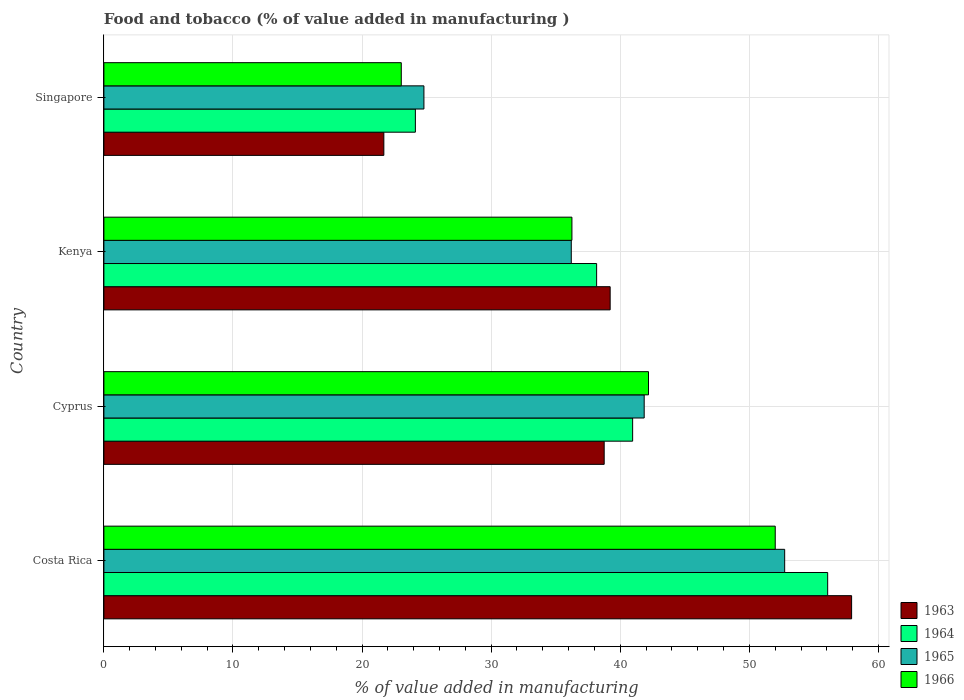How many different coloured bars are there?
Offer a very short reply. 4. How many bars are there on the 2nd tick from the top?
Make the answer very short. 4. What is the label of the 3rd group of bars from the top?
Provide a succinct answer. Cyprus. In how many cases, is the number of bars for a given country not equal to the number of legend labels?
Keep it short and to the point. 0. What is the value added in manufacturing food and tobacco in 1965 in Kenya?
Give a very brief answer. 36.2. Across all countries, what is the maximum value added in manufacturing food and tobacco in 1963?
Make the answer very short. 57.92. Across all countries, what is the minimum value added in manufacturing food and tobacco in 1965?
Offer a terse response. 24.79. In which country was the value added in manufacturing food and tobacco in 1964 minimum?
Make the answer very short. Singapore. What is the total value added in manufacturing food and tobacco in 1966 in the graph?
Keep it short and to the point. 153.48. What is the difference between the value added in manufacturing food and tobacco in 1966 in Costa Rica and that in Cyprus?
Offer a very short reply. 9.82. What is the difference between the value added in manufacturing food and tobacco in 1964 in Costa Rica and the value added in manufacturing food and tobacco in 1963 in Singapore?
Make the answer very short. 34.38. What is the average value added in manufacturing food and tobacco in 1963 per country?
Your response must be concise. 39.39. What is the difference between the value added in manufacturing food and tobacco in 1965 and value added in manufacturing food and tobacco in 1963 in Kenya?
Keep it short and to the point. -3.01. What is the ratio of the value added in manufacturing food and tobacco in 1963 in Costa Rica to that in Cyprus?
Ensure brevity in your answer.  1.49. Is the value added in manufacturing food and tobacco in 1965 in Cyprus less than that in Singapore?
Offer a very short reply. No. What is the difference between the highest and the second highest value added in manufacturing food and tobacco in 1964?
Your answer should be very brief. 15.11. What is the difference between the highest and the lowest value added in manufacturing food and tobacco in 1965?
Your answer should be very brief. 27.94. Is it the case that in every country, the sum of the value added in manufacturing food and tobacco in 1966 and value added in manufacturing food and tobacco in 1963 is greater than the sum of value added in manufacturing food and tobacco in 1964 and value added in manufacturing food and tobacco in 1965?
Ensure brevity in your answer.  No. What does the 3rd bar from the top in Cyprus represents?
Provide a succinct answer. 1964. What does the 4th bar from the bottom in Costa Rica represents?
Your answer should be compact. 1966. Are all the bars in the graph horizontal?
Make the answer very short. Yes. How many countries are there in the graph?
Keep it short and to the point. 4. Does the graph contain any zero values?
Provide a short and direct response. No. How are the legend labels stacked?
Your answer should be very brief. Vertical. What is the title of the graph?
Make the answer very short. Food and tobacco (% of value added in manufacturing ). Does "2008" appear as one of the legend labels in the graph?
Ensure brevity in your answer.  No. What is the label or title of the X-axis?
Offer a very short reply. % of value added in manufacturing. What is the % of value added in manufacturing in 1963 in Costa Rica?
Offer a terse response. 57.92. What is the % of value added in manufacturing of 1964 in Costa Rica?
Offer a very short reply. 56.07. What is the % of value added in manufacturing in 1965 in Costa Rica?
Ensure brevity in your answer.  52.73. What is the % of value added in manufacturing in 1966 in Costa Rica?
Make the answer very short. 52. What is the % of value added in manufacturing of 1963 in Cyprus?
Ensure brevity in your answer.  38.75. What is the % of value added in manufacturing in 1964 in Cyprus?
Your answer should be compact. 40.96. What is the % of value added in manufacturing of 1965 in Cyprus?
Ensure brevity in your answer.  41.85. What is the % of value added in manufacturing of 1966 in Cyprus?
Your response must be concise. 42.19. What is the % of value added in manufacturing of 1963 in Kenya?
Ensure brevity in your answer.  39.22. What is the % of value added in manufacturing of 1964 in Kenya?
Make the answer very short. 38.17. What is the % of value added in manufacturing of 1965 in Kenya?
Provide a succinct answer. 36.2. What is the % of value added in manufacturing of 1966 in Kenya?
Your response must be concise. 36.25. What is the % of value added in manufacturing of 1963 in Singapore?
Offer a terse response. 21.69. What is the % of value added in manufacturing in 1964 in Singapore?
Ensure brevity in your answer.  24.13. What is the % of value added in manufacturing of 1965 in Singapore?
Provide a short and direct response. 24.79. What is the % of value added in manufacturing in 1966 in Singapore?
Make the answer very short. 23.04. Across all countries, what is the maximum % of value added in manufacturing of 1963?
Provide a short and direct response. 57.92. Across all countries, what is the maximum % of value added in manufacturing of 1964?
Make the answer very short. 56.07. Across all countries, what is the maximum % of value added in manufacturing of 1965?
Your answer should be compact. 52.73. Across all countries, what is the maximum % of value added in manufacturing of 1966?
Offer a very short reply. 52. Across all countries, what is the minimum % of value added in manufacturing of 1963?
Your answer should be compact. 21.69. Across all countries, what is the minimum % of value added in manufacturing in 1964?
Make the answer very short. 24.13. Across all countries, what is the minimum % of value added in manufacturing of 1965?
Make the answer very short. 24.79. Across all countries, what is the minimum % of value added in manufacturing in 1966?
Your response must be concise. 23.04. What is the total % of value added in manufacturing of 1963 in the graph?
Your response must be concise. 157.58. What is the total % of value added in manufacturing of 1964 in the graph?
Offer a very short reply. 159.32. What is the total % of value added in manufacturing in 1965 in the graph?
Your response must be concise. 155.58. What is the total % of value added in manufacturing of 1966 in the graph?
Offer a terse response. 153.48. What is the difference between the % of value added in manufacturing in 1963 in Costa Rica and that in Cyprus?
Give a very brief answer. 19.17. What is the difference between the % of value added in manufacturing of 1964 in Costa Rica and that in Cyprus?
Make the answer very short. 15.11. What is the difference between the % of value added in manufacturing of 1965 in Costa Rica and that in Cyprus?
Your response must be concise. 10.88. What is the difference between the % of value added in manufacturing in 1966 in Costa Rica and that in Cyprus?
Ensure brevity in your answer.  9.82. What is the difference between the % of value added in manufacturing in 1963 in Costa Rica and that in Kenya?
Your answer should be compact. 18.7. What is the difference between the % of value added in manufacturing of 1964 in Costa Rica and that in Kenya?
Ensure brevity in your answer.  17.9. What is the difference between the % of value added in manufacturing of 1965 in Costa Rica and that in Kenya?
Offer a terse response. 16.53. What is the difference between the % of value added in manufacturing of 1966 in Costa Rica and that in Kenya?
Make the answer very short. 15.75. What is the difference between the % of value added in manufacturing in 1963 in Costa Rica and that in Singapore?
Make the answer very short. 36.23. What is the difference between the % of value added in manufacturing in 1964 in Costa Rica and that in Singapore?
Your answer should be compact. 31.94. What is the difference between the % of value added in manufacturing in 1965 in Costa Rica and that in Singapore?
Provide a succinct answer. 27.94. What is the difference between the % of value added in manufacturing in 1966 in Costa Rica and that in Singapore?
Provide a short and direct response. 28.97. What is the difference between the % of value added in manufacturing in 1963 in Cyprus and that in Kenya?
Give a very brief answer. -0.46. What is the difference between the % of value added in manufacturing of 1964 in Cyprus and that in Kenya?
Keep it short and to the point. 2.79. What is the difference between the % of value added in manufacturing in 1965 in Cyprus and that in Kenya?
Give a very brief answer. 5.65. What is the difference between the % of value added in manufacturing of 1966 in Cyprus and that in Kenya?
Provide a succinct answer. 5.93. What is the difference between the % of value added in manufacturing in 1963 in Cyprus and that in Singapore?
Provide a succinct answer. 17.07. What is the difference between the % of value added in manufacturing of 1964 in Cyprus and that in Singapore?
Offer a terse response. 16.83. What is the difference between the % of value added in manufacturing of 1965 in Cyprus and that in Singapore?
Give a very brief answer. 17.06. What is the difference between the % of value added in manufacturing in 1966 in Cyprus and that in Singapore?
Your response must be concise. 19.15. What is the difference between the % of value added in manufacturing of 1963 in Kenya and that in Singapore?
Your answer should be compact. 17.53. What is the difference between the % of value added in manufacturing in 1964 in Kenya and that in Singapore?
Ensure brevity in your answer.  14.04. What is the difference between the % of value added in manufacturing of 1965 in Kenya and that in Singapore?
Your response must be concise. 11.41. What is the difference between the % of value added in manufacturing of 1966 in Kenya and that in Singapore?
Offer a terse response. 13.22. What is the difference between the % of value added in manufacturing in 1963 in Costa Rica and the % of value added in manufacturing in 1964 in Cyprus?
Give a very brief answer. 16.96. What is the difference between the % of value added in manufacturing of 1963 in Costa Rica and the % of value added in manufacturing of 1965 in Cyprus?
Give a very brief answer. 16.07. What is the difference between the % of value added in manufacturing in 1963 in Costa Rica and the % of value added in manufacturing in 1966 in Cyprus?
Provide a short and direct response. 15.73. What is the difference between the % of value added in manufacturing of 1964 in Costa Rica and the % of value added in manufacturing of 1965 in Cyprus?
Offer a very short reply. 14.21. What is the difference between the % of value added in manufacturing of 1964 in Costa Rica and the % of value added in manufacturing of 1966 in Cyprus?
Offer a terse response. 13.88. What is the difference between the % of value added in manufacturing in 1965 in Costa Rica and the % of value added in manufacturing in 1966 in Cyprus?
Your answer should be compact. 10.55. What is the difference between the % of value added in manufacturing of 1963 in Costa Rica and the % of value added in manufacturing of 1964 in Kenya?
Your answer should be very brief. 19.75. What is the difference between the % of value added in manufacturing of 1963 in Costa Rica and the % of value added in manufacturing of 1965 in Kenya?
Ensure brevity in your answer.  21.72. What is the difference between the % of value added in manufacturing of 1963 in Costa Rica and the % of value added in manufacturing of 1966 in Kenya?
Provide a succinct answer. 21.67. What is the difference between the % of value added in manufacturing in 1964 in Costa Rica and the % of value added in manufacturing in 1965 in Kenya?
Ensure brevity in your answer.  19.86. What is the difference between the % of value added in manufacturing in 1964 in Costa Rica and the % of value added in manufacturing in 1966 in Kenya?
Offer a very short reply. 19.81. What is the difference between the % of value added in manufacturing in 1965 in Costa Rica and the % of value added in manufacturing in 1966 in Kenya?
Offer a terse response. 16.48. What is the difference between the % of value added in manufacturing of 1963 in Costa Rica and the % of value added in manufacturing of 1964 in Singapore?
Provide a short and direct response. 33.79. What is the difference between the % of value added in manufacturing of 1963 in Costa Rica and the % of value added in manufacturing of 1965 in Singapore?
Make the answer very short. 33.13. What is the difference between the % of value added in manufacturing in 1963 in Costa Rica and the % of value added in manufacturing in 1966 in Singapore?
Your answer should be compact. 34.88. What is the difference between the % of value added in manufacturing in 1964 in Costa Rica and the % of value added in manufacturing in 1965 in Singapore?
Your response must be concise. 31.28. What is the difference between the % of value added in manufacturing of 1964 in Costa Rica and the % of value added in manufacturing of 1966 in Singapore?
Your answer should be compact. 33.03. What is the difference between the % of value added in manufacturing of 1965 in Costa Rica and the % of value added in manufacturing of 1966 in Singapore?
Your answer should be compact. 29.7. What is the difference between the % of value added in manufacturing of 1963 in Cyprus and the % of value added in manufacturing of 1964 in Kenya?
Provide a short and direct response. 0.59. What is the difference between the % of value added in manufacturing of 1963 in Cyprus and the % of value added in manufacturing of 1965 in Kenya?
Make the answer very short. 2.55. What is the difference between the % of value added in manufacturing in 1963 in Cyprus and the % of value added in manufacturing in 1966 in Kenya?
Your answer should be very brief. 2.5. What is the difference between the % of value added in manufacturing in 1964 in Cyprus and the % of value added in manufacturing in 1965 in Kenya?
Offer a terse response. 4.75. What is the difference between the % of value added in manufacturing in 1964 in Cyprus and the % of value added in manufacturing in 1966 in Kenya?
Offer a very short reply. 4.7. What is the difference between the % of value added in manufacturing of 1965 in Cyprus and the % of value added in manufacturing of 1966 in Kenya?
Ensure brevity in your answer.  5.6. What is the difference between the % of value added in manufacturing in 1963 in Cyprus and the % of value added in manufacturing in 1964 in Singapore?
Your answer should be compact. 14.63. What is the difference between the % of value added in manufacturing in 1963 in Cyprus and the % of value added in manufacturing in 1965 in Singapore?
Your answer should be very brief. 13.96. What is the difference between the % of value added in manufacturing in 1963 in Cyprus and the % of value added in manufacturing in 1966 in Singapore?
Your response must be concise. 15.72. What is the difference between the % of value added in manufacturing of 1964 in Cyprus and the % of value added in manufacturing of 1965 in Singapore?
Your answer should be compact. 16.17. What is the difference between the % of value added in manufacturing of 1964 in Cyprus and the % of value added in manufacturing of 1966 in Singapore?
Give a very brief answer. 17.92. What is the difference between the % of value added in manufacturing of 1965 in Cyprus and the % of value added in manufacturing of 1966 in Singapore?
Your answer should be compact. 18.82. What is the difference between the % of value added in manufacturing in 1963 in Kenya and the % of value added in manufacturing in 1964 in Singapore?
Make the answer very short. 15.09. What is the difference between the % of value added in manufacturing in 1963 in Kenya and the % of value added in manufacturing in 1965 in Singapore?
Make the answer very short. 14.43. What is the difference between the % of value added in manufacturing of 1963 in Kenya and the % of value added in manufacturing of 1966 in Singapore?
Keep it short and to the point. 16.18. What is the difference between the % of value added in manufacturing of 1964 in Kenya and the % of value added in manufacturing of 1965 in Singapore?
Provide a succinct answer. 13.38. What is the difference between the % of value added in manufacturing in 1964 in Kenya and the % of value added in manufacturing in 1966 in Singapore?
Offer a terse response. 15.13. What is the difference between the % of value added in manufacturing of 1965 in Kenya and the % of value added in manufacturing of 1966 in Singapore?
Your response must be concise. 13.17. What is the average % of value added in manufacturing of 1963 per country?
Your answer should be very brief. 39.39. What is the average % of value added in manufacturing in 1964 per country?
Ensure brevity in your answer.  39.83. What is the average % of value added in manufacturing in 1965 per country?
Give a very brief answer. 38.9. What is the average % of value added in manufacturing in 1966 per country?
Ensure brevity in your answer.  38.37. What is the difference between the % of value added in manufacturing of 1963 and % of value added in manufacturing of 1964 in Costa Rica?
Your answer should be very brief. 1.85. What is the difference between the % of value added in manufacturing in 1963 and % of value added in manufacturing in 1965 in Costa Rica?
Your response must be concise. 5.19. What is the difference between the % of value added in manufacturing of 1963 and % of value added in manufacturing of 1966 in Costa Rica?
Your answer should be compact. 5.92. What is the difference between the % of value added in manufacturing in 1964 and % of value added in manufacturing in 1965 in Costa Rica?
Your answer should be compact. 3.33. What is the difference between the % of value added in manufacturing of 1964 and % of value added in manufacturing of 1966 in Costa Rica?
Your answer should be very brief. 4.06. What is the difference between the % of value added in manufacturing of 1965 and % of value added in manufacturing of 1966 in Costa Rica?
Ensure brevity in your answer.  0.73. What is the difference between the % of value added in manufacturing in 1963 and % of value added in manufacturing in 1964 in Cyprus?
Make the answer very short. -2.2. What is the difference between the % of value added in manufacturing of 1963 and % of value added in manufacturing of 1965 in Cyprus?
Your response must be concise. -3.1. What is the difference between the % of value added in manufacturing of 1963 and % of value added in manufacturing of 1966 in Cyprus?
Your response must be concise. -3.43. What is the difference between the % of value added in manufacturing of 1964 and % of value added in manufacturing of 1965 in Cyprus?
Provide a succinct answer. -0.9. What is the difference between the % of value added in manufacturing in 1964 and % of value added in manufacturing in 1966 in Cyprus?
Keep it short and to the point. -1.23. What is the difference between the % of value added in manufacturing of 1965 and % of value added in manufacturing of 1966 in Cyprus?
Provide a succinct answer. -0.33. What is the difference between the % of value added in manufacturing in 1963 and % of value added in manufacturing in 1964 in Kenya?
Provide a short and direct response. 1.05. What is the difference between the % of value added in manufacturing in 1963 and % of value added in manufacturing in 1965 in Kenya?
Provide a short and direct response. 3.01. What is the difference between the % of value added in manufacturing in 1963 and % of value added in manufacturing in 1966 in Kenya?
Keep it short and to the point. 2.96. What is the difference between the % of value added in manufacturing in 1964 and % of value added in manufacturing in 1965 in Kenya?
Your response must be concise. 1.96. What is the difference between the % of value added in manufacturing of 1964 and % of value added in manufacturing of 1966 in Kenya?
Ensure brevity in your answer.  1.91. What is the difference between the % of value added in manufacturing in 1965 and % of value added in manufacturing in 1966 in Kenya?
Offer a very short reply. -0.05. What is the difference between the % of value added in manufacturing in 1963 and % of value added in manufacturing in 1964 in Singapore?
Ensure brevity in your answer.  -2.44. What is the difference between the % of value added in manufacturing in 1963 and % of value added in manufacturing in 1965 in Singapore?
Your answer should be compact. -3.1. What is the difference between the % of value added in manufacturing of 1963 and % of value added in manufacturing of 1966 in Singapore?
Your answer should be compact. -1.35. What is the difference between the % of value added in manufacturing of 1964 and % of value added in manufacturing of 1965 in Singapore?
Keep it short and to the point. -0.66. What is the difference between the % of value added in manufacturing in 1964 and % of value added in manufacturing in 1966 in Singapore?
Ensure brevity in your answer.  1.09. What is the difference between the % of value added in manufacturing of 1965 and % of value added in manufacturing of 1966 in Singapore?
Your answer should be compact. 1.75. What is the ratio of the % of value added in manufacturing in 1963 in Costa Rica to that in Cyprus?
Your answer should be very brief. 1.49. What is the ratio of the % of value added in manufacturing in 1964 in Costa Rica to that in Cyprus?
Give a very brief answer. 1.37. What is the ratio of the % of value added in manufacturing of 1965 in Costa Rica to that in Cyprus?
Keep it short and to the point. 1.26. What is the ratio of the % of value added in manufacturing in 1966 in Costa Rica to that in Cyprus?
Your answer should be compact. 1.23. What is the ratio of the % of value added in manufacturing of 1963 in Costa Rica to that in Kenya?
Your response must be concise. 1.48. What is the ratio of the % of value added in manufacturing in 1964 in Costa Rica to that in Kenya?
Ensure brevity in your answer.  1.47. What is the ratio of the % of value added in manufacturing of 1965 in Costa Rica to that in Kenya?
Give a very brief answer. 1.46. What is the ratio of the % of value added in manufacturing in 1966 in Costa Rica to that in Kenya?
Your response must be concise. 1.43. What is the ratio of the % of value added in manufacturing in 1963 in Costa Rica to that in Singapore?
Make the answer very short. 2.67. What is the ratio of the % of value added in manufacturing of 1964 in Costa Rica to that in Singapore?
Provide a succinct answer. 2.32. What is the ratio of the % of value added in manufacturing in 1965 in Costa Rica to that in Singapore?
Provide a succinct answer. 2.13. What is the ratio of the % of value added in manufacturing in 1966 in Costa Rica to that in Singapore?
Your answer should be very brief. 2.26. What is the ratio of the % of value added in manufacturing of 1964 in Cyprus to that in Kenya?
Provide a short and direct response. 1.07. What is the ratio of the % of value added in manufacturing in 1965 in Cyprus to that in Kenya?
Your answer should be very brief. 1.16. What is the ratio of the % of value added in manufacturing of 1966 in Cyprus to that in Kenya?
Offer a terse response. 1.16. What is the ratio of the % of value added in manufacturing in 1963 in Cyprus to that in Singapore?
Your answer should be compact. 1.79. What is the ratio of the % of value added in manufacturing in 1964 in Cyprus to that in Singapore?
Your response must be concise. 1.7. What is the ratio of the % of value added in manufacturing in 1965 in Cyprus to that in Singapore?
Keep it short and to the point. 1.69. What is the ratio of the % of value added in manufacturing in 1966 in Cyprus to that in Singapore?
Your answer should be compact. 1.83. What is the ratio of the % of value added in manufacturing in 1963 in Kenya to that in Singapore?
Provide a succinct answer. 1.81. What is the ratio of the % of value added in manufacturing in 1964 in Kenya to that in Singapore?
Offer a very short reply. 1.58. What is the ratio of the % of value added in manufacturing of 1965 in Kenya to that in Singapore?
Keep it short and to the point. 1.46. What is the ratio of the % of value added in manufacturing of 1966 in Kenya to that in Singapore?
Your answer should be very brief. 1.57. What is the difference between the highest and the second highest % of value added in manufacturing of 1963?
Your response must be concise. 18.7. What is the difference between the highest and the second highest % of value added in manufacturing of 1964?
Your response must be concise. 15.11. What is the difference between the highest and the second highest % of value added in manufacturing in 1965?
Your response must be concise. 10.88. What is the difference between the highest and the second highest % of value added in manufacturing of 1966?
Offer a very short reply. 9.82. What is the difference between the highest and the lowest % of value added in manufacturing of 1963?
Offer a very short reply. 36.23. What is the difference between the highest and the lowest % of value added in manufacturing in 1964?
Make the answer very short. 31.94. What is the difference between the highest and the lowest % of value added in manufacturing in 1965?
Ensure brevity in your answer.  27.94. What is the difference between the highest and the lowest % of value added in manufacturing in 1966?
Offer a terse response. 28.97. 